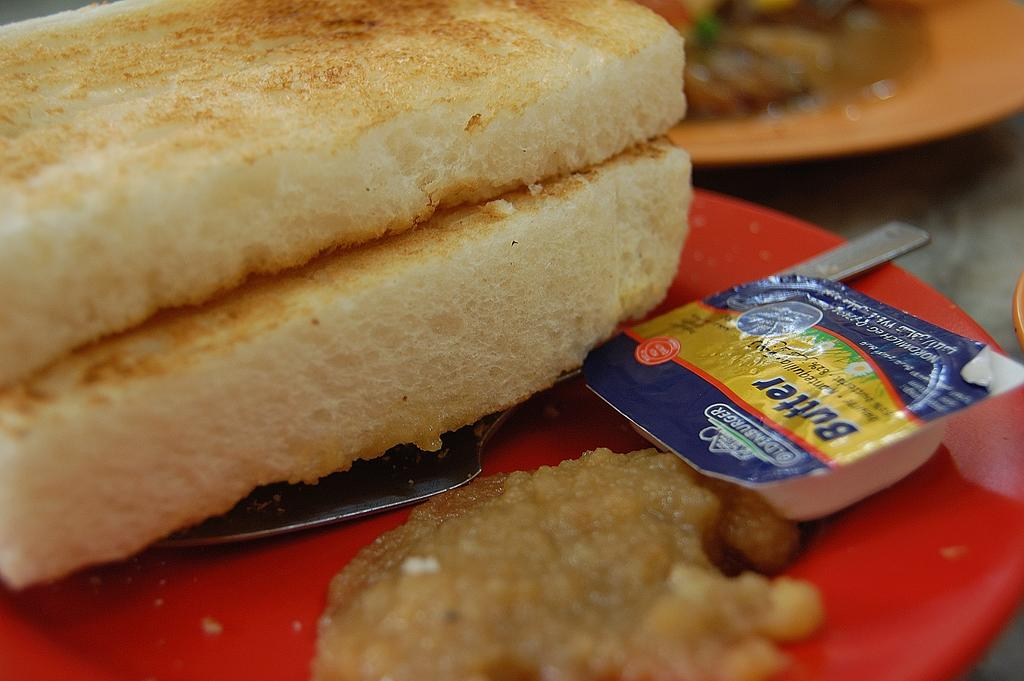What is the color of the plate that holds the food item in the image? The plate is red. What utensil is placed on the red plate? There is a knife on the red plate. How would you describe the background of the image? The background of the image is slightly blurred. Can you see any other plates with food items in the image? Yes, there is another plate with a food item in the background. What question is being asked in the image? There is no question being asked in the image. 